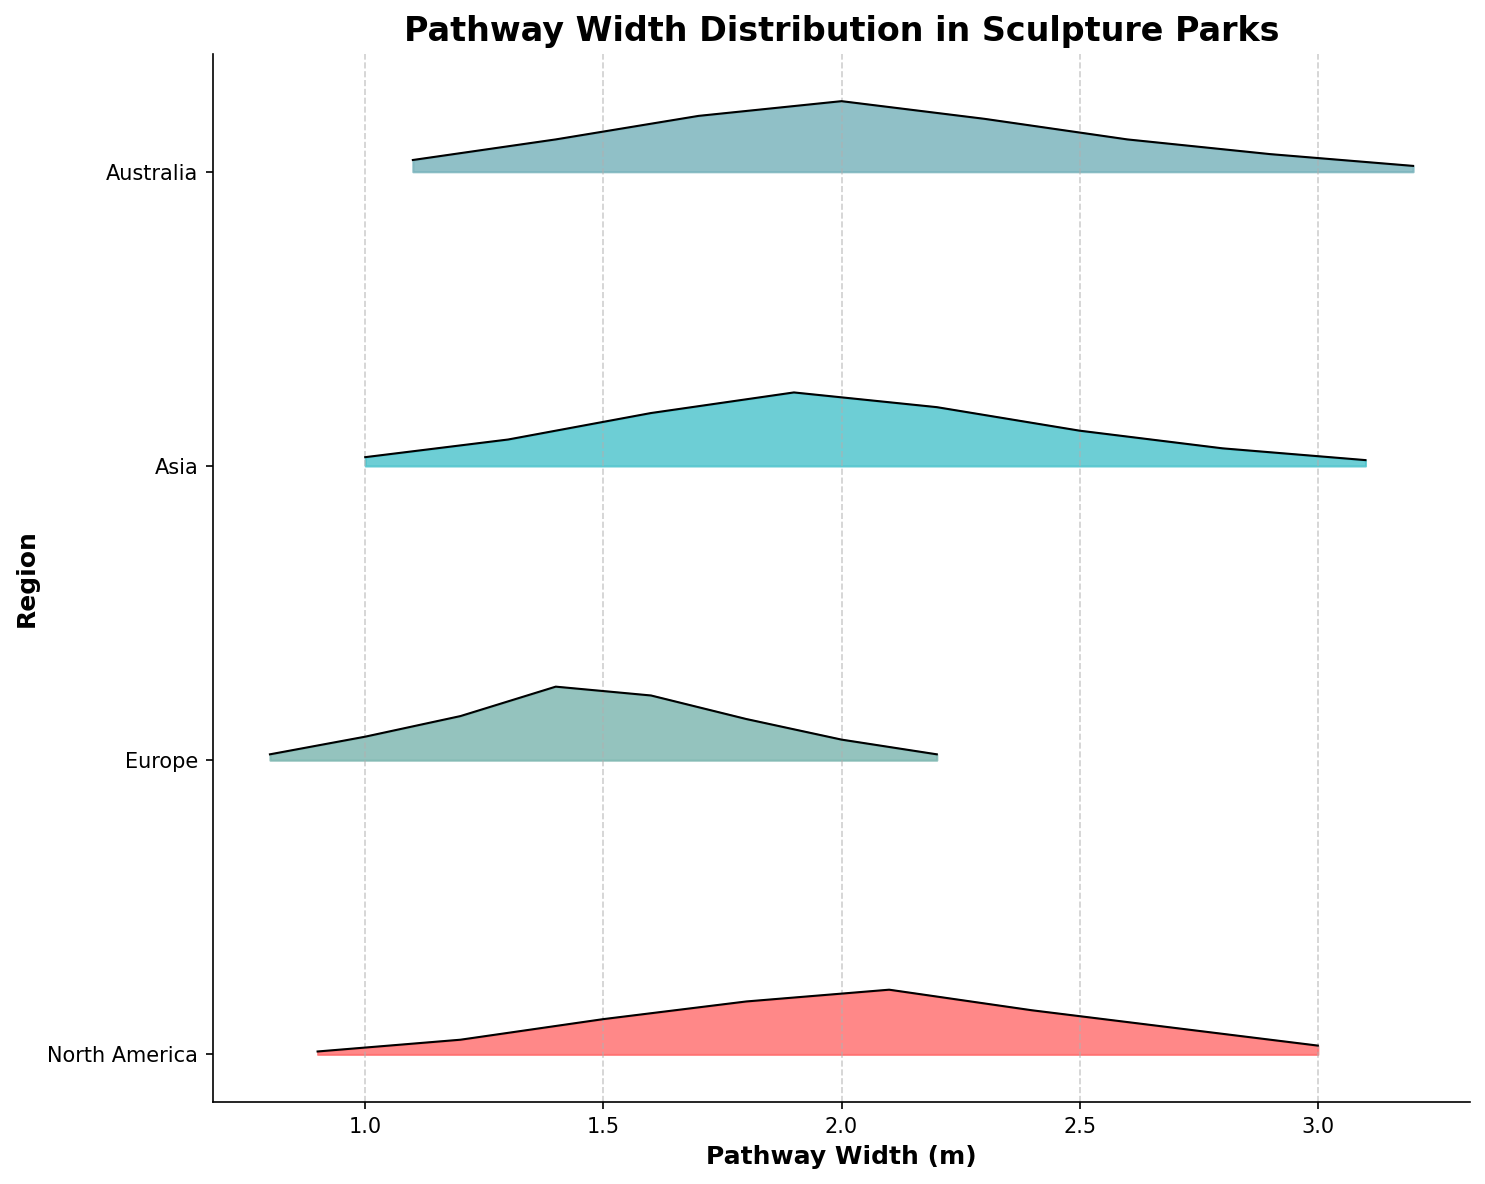What is the title of the plot? The title is located at the top of the figure and provides an overview of the main subject, which is the pathway width distribution in sculpture parks across regions.
Answer: Pathway Width Distribution in Sculpture Parks How many regions are displayed in the plot? By counting the distinct y-tick labels on the y-axis, we can determine the number of regions. Here, there are four labels indicating four regions.
Answer: Four What is the pathway width with the highest density in North America? The peak of the ridgeline plot for North America can be observed to identify the width with the highest density. The highest density appears around 2.1 meters.
Answer: 2.1 meters Which region has the widest range of pathway widths? By visually comparing the x-axis spread for each region's plot, Asia's widths range from 1.0 to 3.1 meters, making it the widest range compared to other regions.
Answer: Asia Which region shows the most even distribution of pathway widths? Visual inspection of the ridgelines indicates that Europe has a more gradual change in densities across widths, suggesting a more even distribution compared to other regions with sharper peaks and drops.
Answer: Europe Between Europe and Australia, which region has the highest peak density in pathway width distribution? Comparing the height of the peaks between the two regions, Australia’s peak at around 2.0 meters appears higher than Europe’s highest peak at approximately 1.4 meters.
Answer: Australia What pathway width is most common in Asia? The peak of the ridgeline for the Asia region represents the most common pathway width. This occurs around 1.9 meters where its density is the highest.
Answer: 1.9 meters In which width range does Europe have the most concentrated pathway densities? By examining the ridgeline for Europe, the highest densities are noted between 1.2 to 1.6 meters, indicating this range has the most concentrated pathway densities.
Answer: 1.2 to 1.6 meters Can you compare the variability in pathway widths between North America and Asia? North America shows a narrower range from 0.9 to 3.0 meters with a single peak, suggesting less variability, while Asia ranges from 1.0 to 3.1 meters with multiple density peaks, indicating higher variability.
Answer: Asia has more variability than North America How does the density of pathway widths in Europe around 1.4 meters compare to Australia? By examining the heights of the ridgelines at 1.4 meters for both regions, Europe has a noticeably higher density than Australia, suggesting more pathways in Europe are near this width.
Answer: Europe has a higher density 